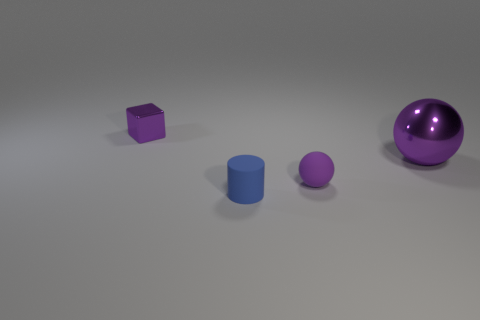Is the number of big purple things that are on the left side of the tiny blue thing less than the number of large purple balls to the left of the tiny rubber ball?
Give a very brief answer. No. What number of small green rubber cylinders are there?
Your answer should be compact. 0. What color is the small metallic thing behind the big shiny object?
Your response must be concise. Purple. How big is the purple cube?
Ensure brevity in your answer.  Small. There is a cylinder; is it the same color as the metal thing on the right side of the small purple cube?
Give a very brief answer. No. The rubber thing that is left of the sphere in front of the large shiny object is what color?
Your answer should be compact. Blue. Is there any other thing that has the same size as the blue rubber cylinder?
Offer a terse response. Yes. There is a purple metal object that is to the right of the purple cube; is its shape the same as the tiny blue matte object?
Keep it short and to the point. No. How many purple things are in front of the small metal thing and on the left side of the blue rubber object?
Provide a short and direct response. 0. What color is the metal object that is in front of the purple metal object behind the metallic sphere that is to the right of the tiny blue matte cylinder?
Keep it short and to the point. Purple. 